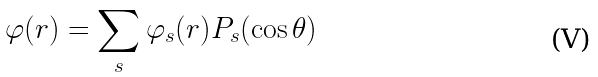<formula> <loc_0><loc_0><loc_500><loc_500>\varphi ( { r } ) = \sum _ { s } \varphi _ { s } ( r ) P _ { s } ( \cos \theta )</formula> 